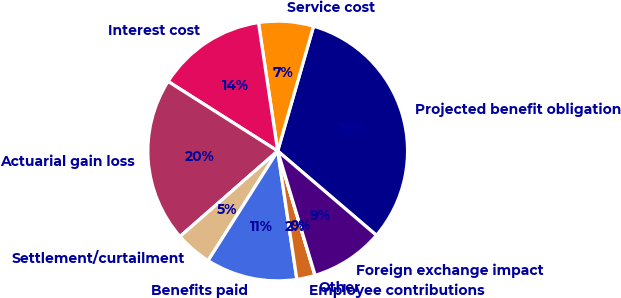Convert chart to OTSL. <chart><loc_0><loc_0><loc_500><loc_500><pie_chart><fcel>Projected benefit obligation<fcel>Service cost<fcel>Interest cost<fcel>Actuarial gain loss<fcel>Settlement/curtailment<fcel>Benefits paid<fcel>Employee contributions<fcel>Other<fcel>Foreign exchange impact<nl><fcel>31.79%<fcel>6.82%<fcel>13.63%<fcel>20.44%<fcel>4.55%<fcel>11.36%<fcel>2.28%<fcel>0.02%<fcel>9.09%<nl></chart> 